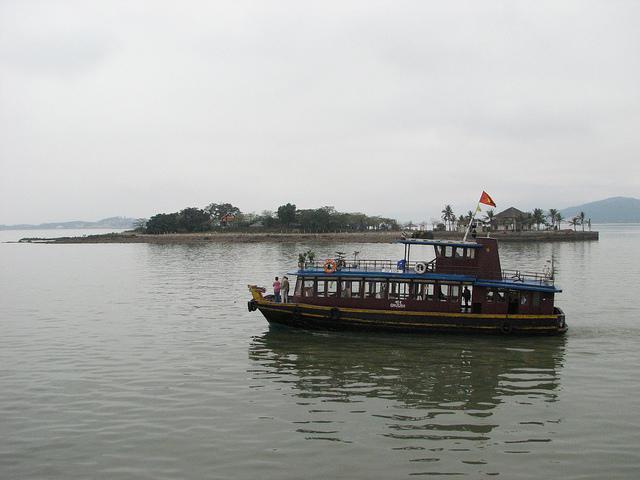How many different kinds of flags are posted on the boat?
Give a very brief answer. 1. How many surfboards are shown?
Give a very brief answer. 0. 